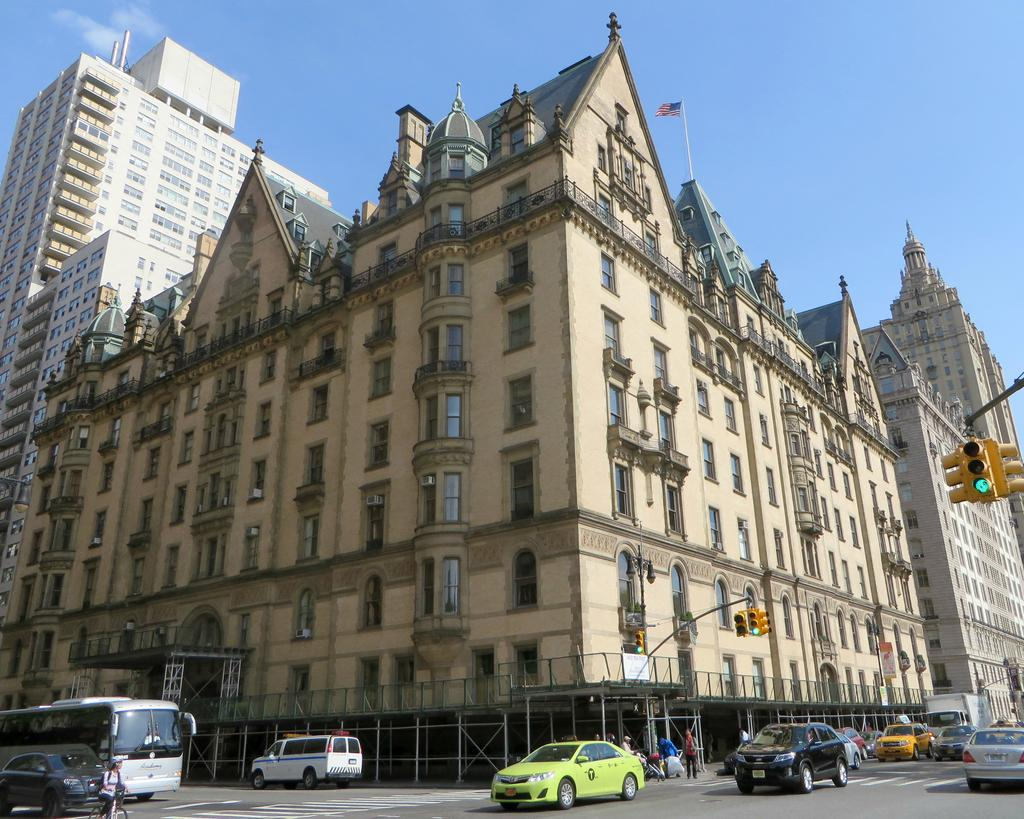What type of structures can be seen in the image? There are buildings in the image. What else is visible on the ground in the image? There are vehicles on the road in the image. Where is the signal light located in the image? The signal light is on the right side of the image. What is visible at the top of the image? The sky is visible at the top of the image. How many chairs can be seen in the image? There are no chairs present in the image. What type of bait is being used by the dinosaurs in the image? There are no dinosaurs present in the image, so there is no bait being used. 